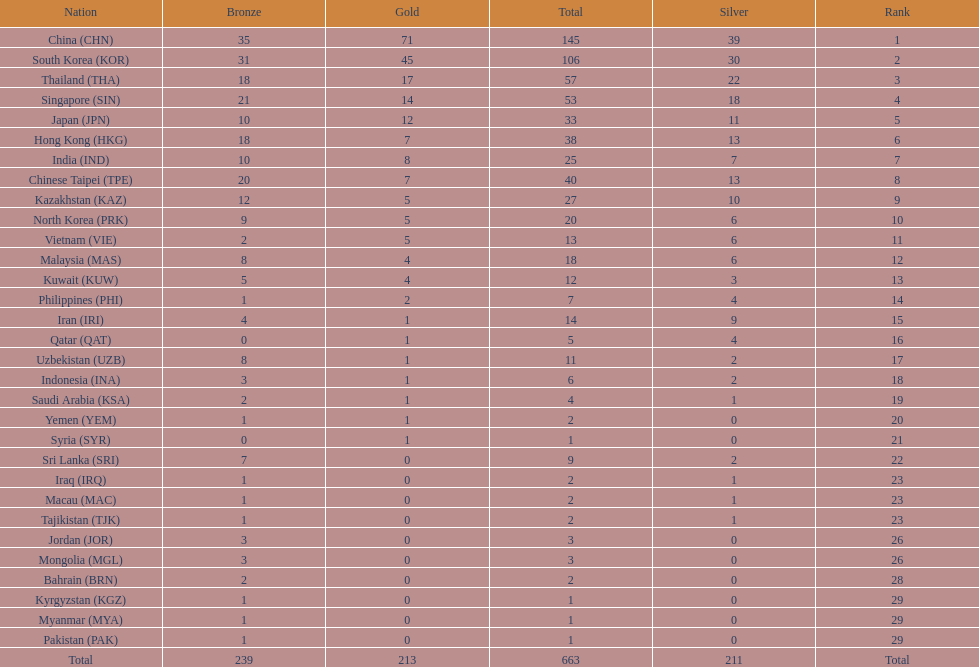Which nation has more gold medals, kuwait or india? India (IND). 